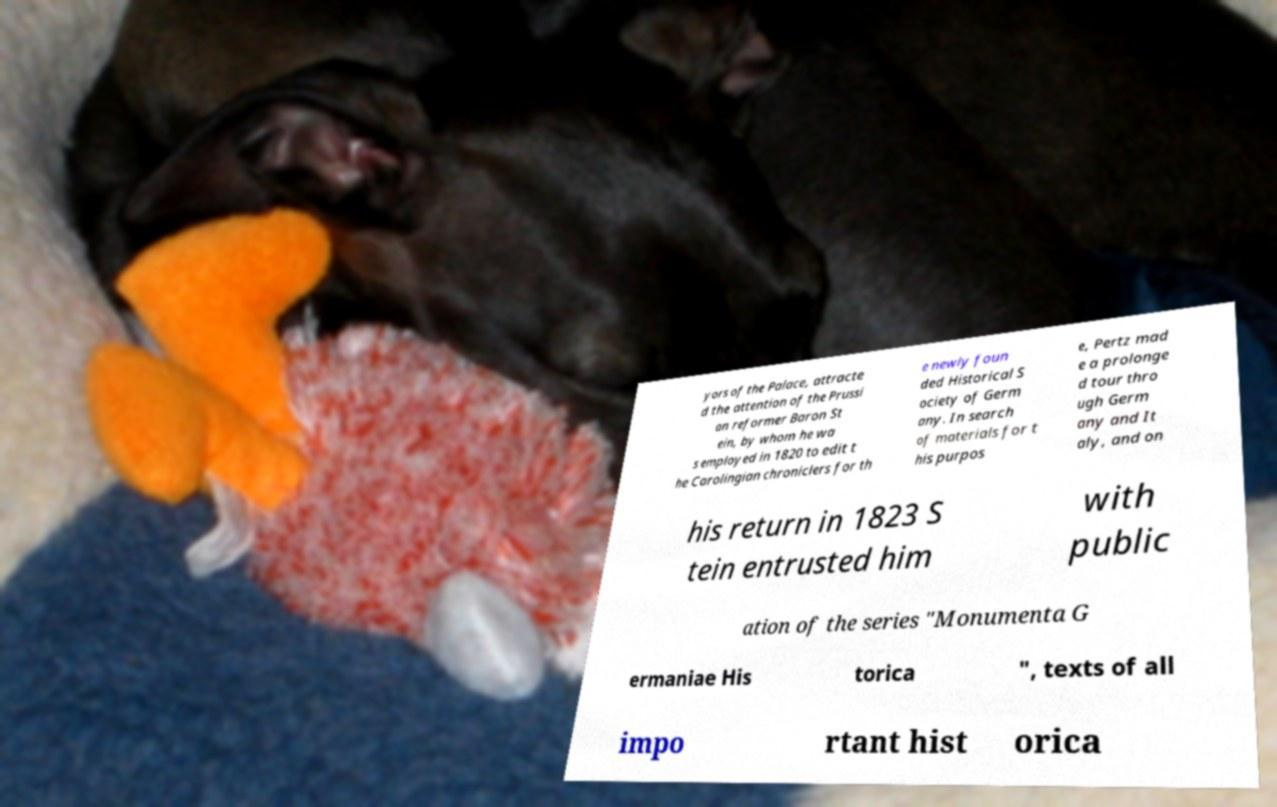What messages or text are displayed in this image? I need them in a readable, typed format. yors of the Palace, attracte d the attention of the Prussi an reformer Baron St ein, by whom he wa s employed in 1820 to edit t he Carolingian chroniclers for th e newly foun ded Historical S ociety of Germ any. In search of materials for t his purpos e, Pertz mad e a prolonge d tour thro ugh Germ any and It aly, and on his return in 1823 S tein entrusted him with public ation of the series "Monumenta G ermaniae His torica ", texts of all impo rtant hist orica 